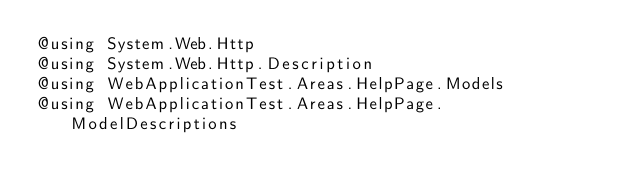<code> <loc_0><loc_0><loc_500><loc_500><_C#_>@using System.Web.Http
@using System.Web.Http.Description
@using WebApplicationTest.Areas.HelpPage.Models
@using WebApplicationTest.Areas.HelpPage.ModelDescriptions</code> 